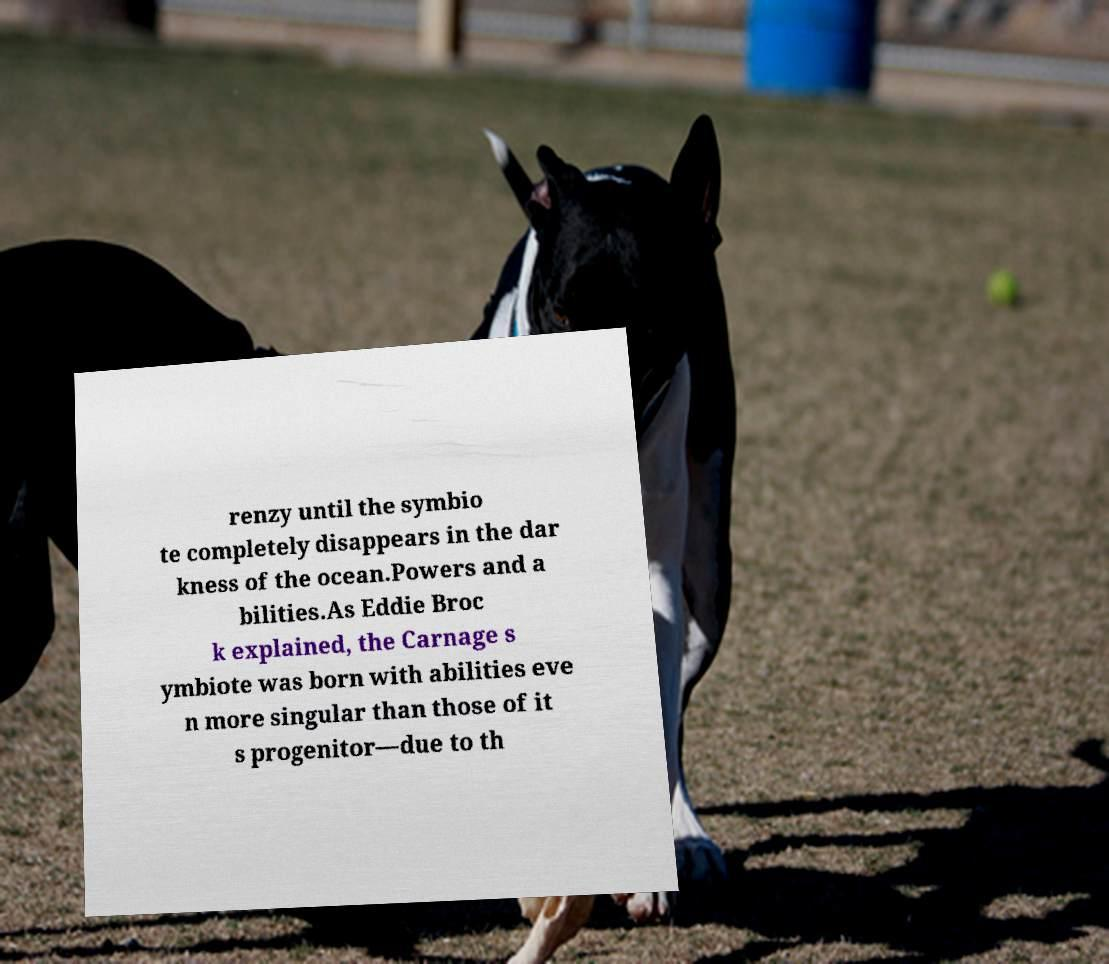Please read and relay the text visible in this image. What does it say? renzy until the symbio te completely disappears in the dar kness of the ocean.Powers and a bilities.As Eddie Broc k explained, the Carnage s ymbiote was born with abilities eve n more singular than those of it s progenitor—due to th 